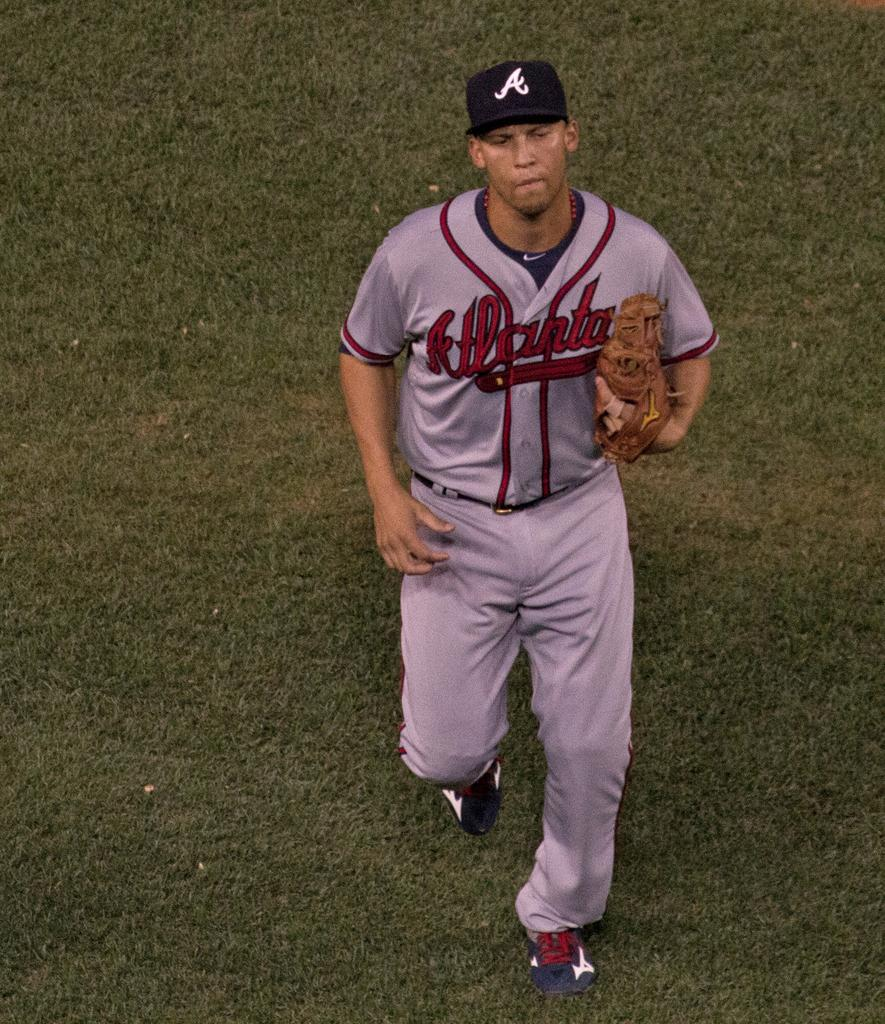<image>
Create a compact narrative representing the image presented. a person that is wearing an Atlanta baseball jersey 